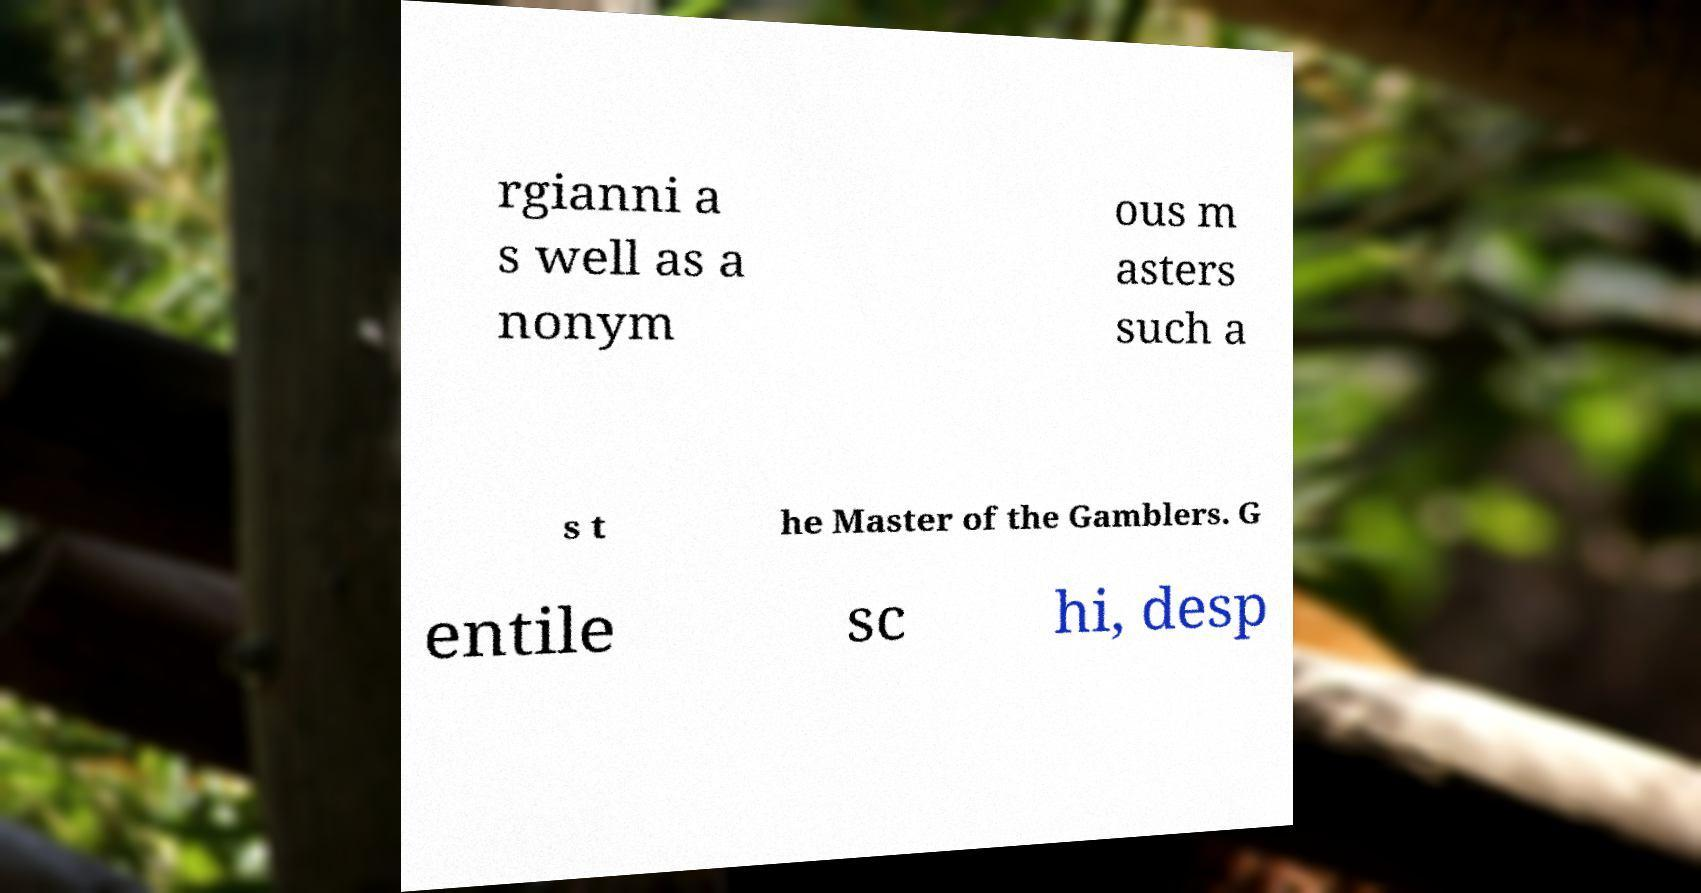I need the written content from this picture converted into text. Can you do that? rgianni a s well as a nonym ous m asters such a s t he Master of the Gamblers. G entile sc hi, desp 